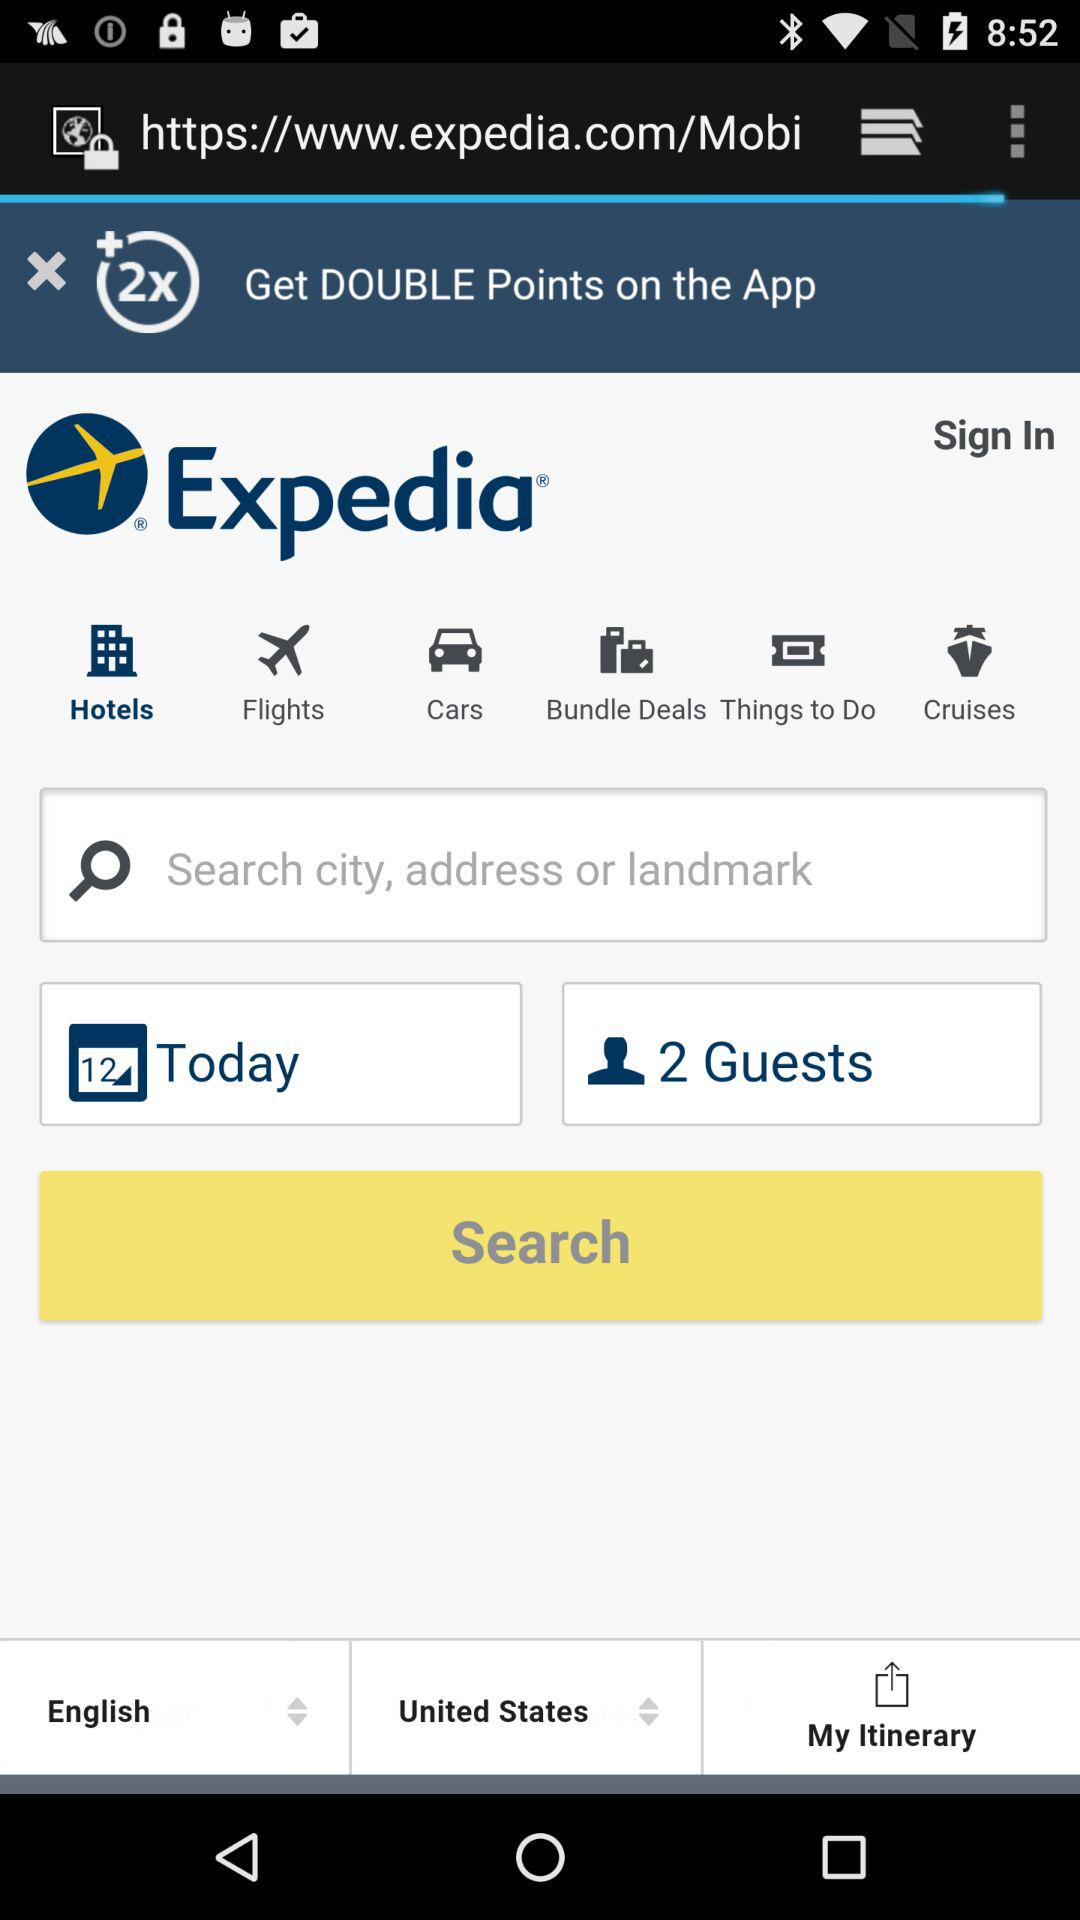What is the count of guests? The count of guests is 2. 